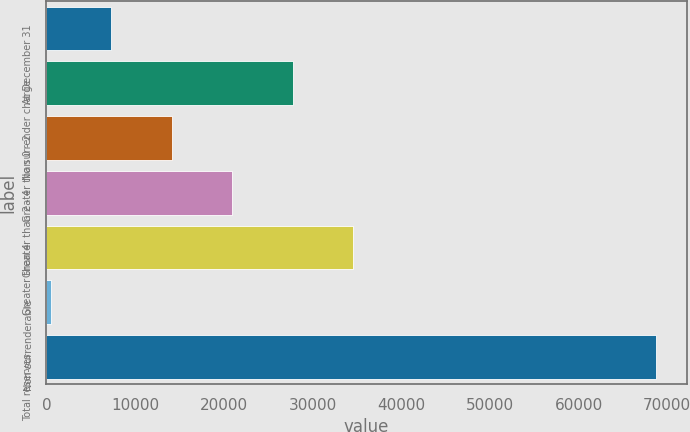Convert chart to OTSL. <chart><loc_0><loc_0><loc_500><loc_500><bar_chart><fcel>At December 31<fcel>No surrender charge<fcel>Greater than 0 - 2<fcel>Greater than 2 - 4<fcel>Greater than 4<fcel>Non-surrenderable<fcel>Total reserves<nl><fcel>7303<fcel>27790<fcel>14132<fcel>20961<fcel>34619<fcel>474<fcel>68764<nl></chart> 